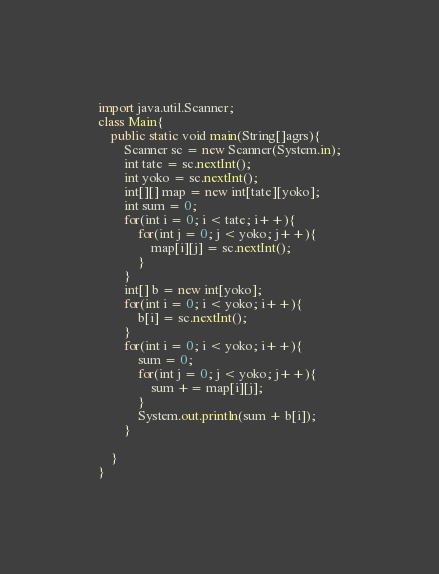<code> <loc_0><loc_0><loc_500><loc_500><_Java_>import java.util.Scanner;
class Main{
	public static void main(String[]agrs){
		Scanner sc = new Scanner(System.in);
		int tate = sc.nextInt();
		int yoko = sc.nextInt();
		int[][] map = new int[tate][yoko];
		int sum = 0;
		for(int i = 0; i < tate; i++){
			for(int j = 0; j < yoko; j++){
				map[i][j] = sc.nextInt();
			}
		}
		int[] b = new int[yoko];
		for(int i = 0; i < yoko; i++){
			b[i] = sc.nextInt();
		}
		for(int i = 0; i < yoko; i++){
			sum = 0;
			for(int j = 0; j < yoko; j++){
				sum += map[i][j];
			}
			System.out.println(sum + b[i]);
		}

	}
}</code> 